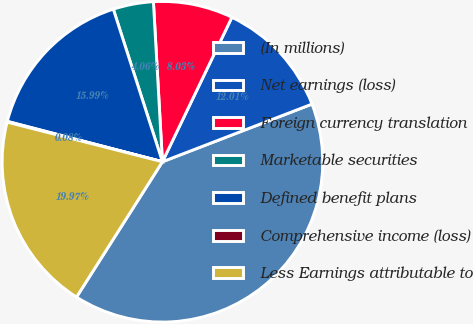<chart> <loc_0><loc_0><loc_500><loc_500><pie_chart><fcel>(In millions)<fcel>Net earnings (loss)<fcel>Foreign currency translation<fcel>Marketable securities<fcel>Defined benefit plans<fcel>Comprehensive income (loss)<fcel>Less Earnings attributable to<nl><fcel>39.86%<fcel>12.01%<fcel>8.03%<fcel>4.06%<fcel>15.99%<fcel>0.08%<fcel>19.97%<nl></chart> 